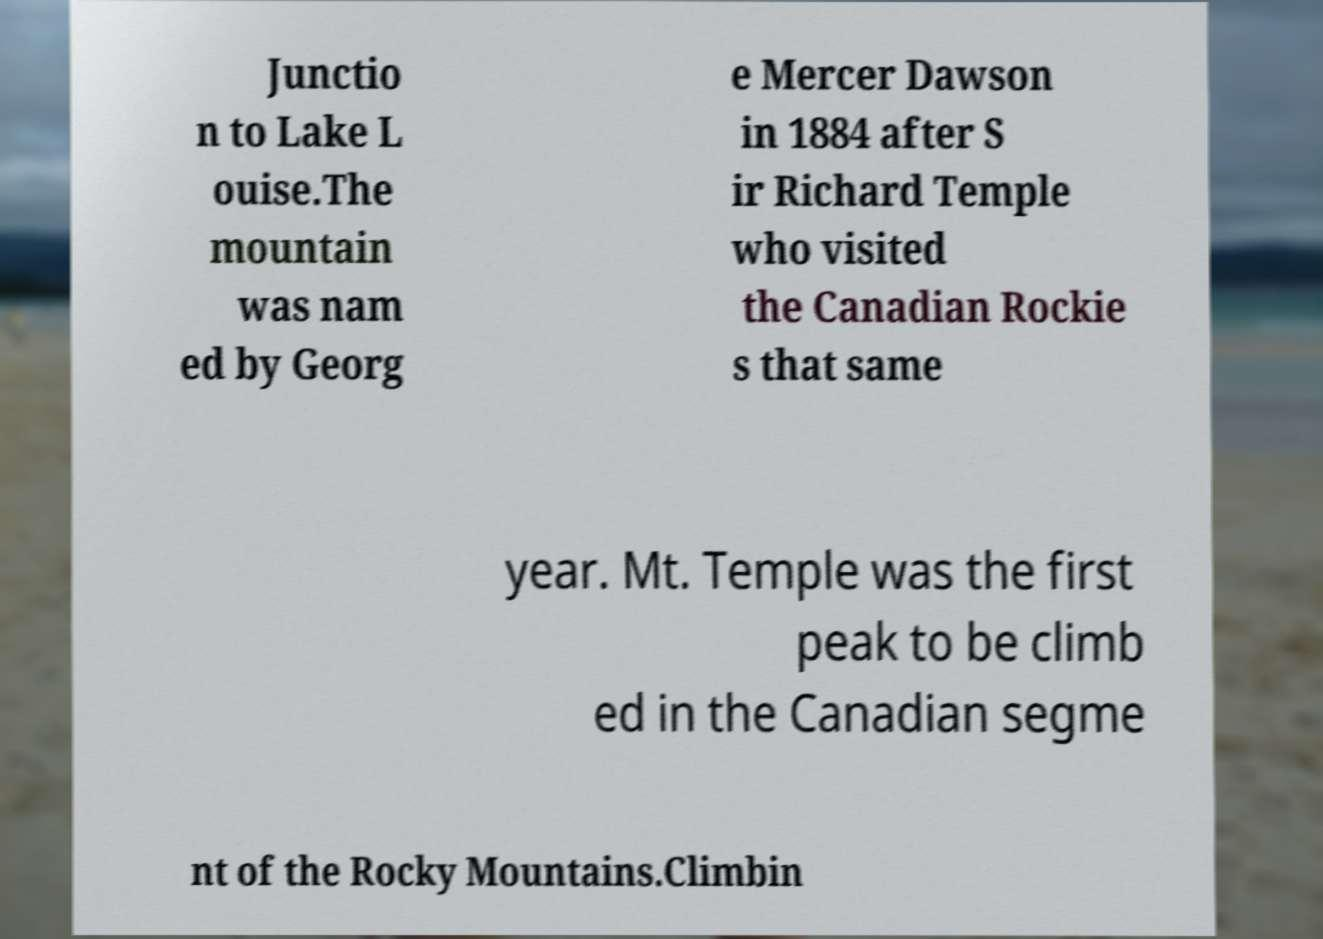Can you read and provide the text displayed in the image?This photo seems to have some interesting text. Can you extract and type it out for me? Junctio n to Lake L ouise.The mountain was nam ed by Georg e Mercer Dawson in 1884 after S ir Richard Temple who visited the Canadian Rockie s that same year. Mt. Temple was the first peak to be climb ed in the Canadian segme nt of the Rocky Mountains.Climbin 